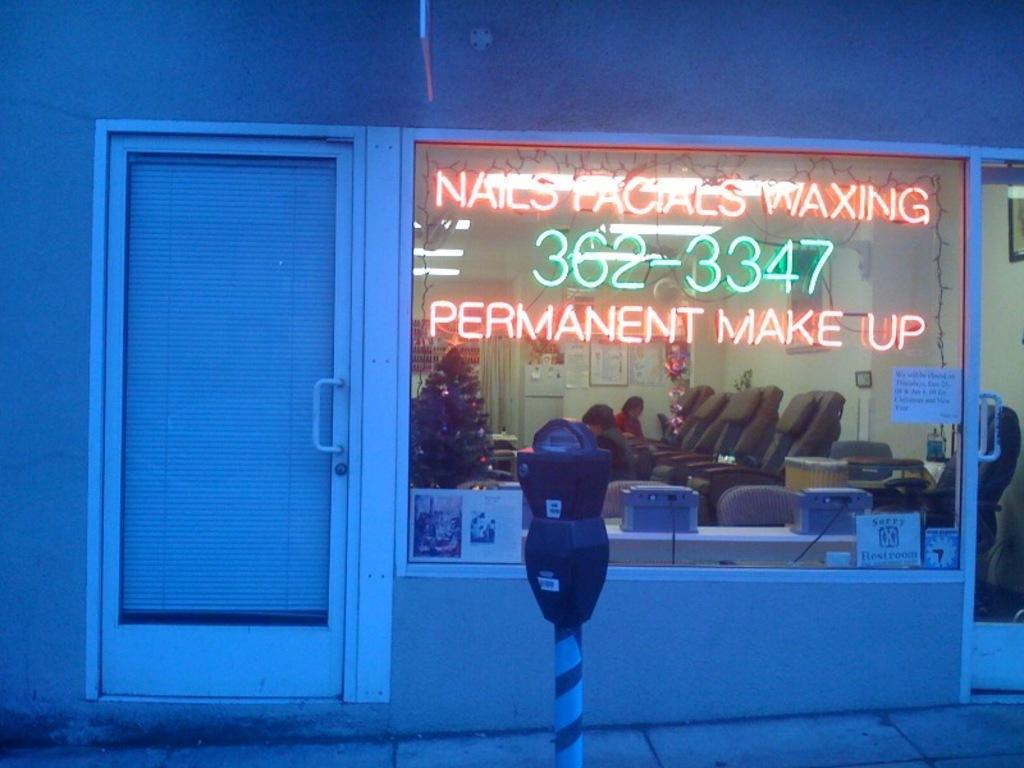In one or two sentences, can you explain what this image depicts? In front of the picture, we see a speedometer. Behind that, we see a glass window and a door from which we can see chairs, Christmas tree, a wall on which many photo frames and are placed. We even see two people sitting on the chairs. Beside that, we see a white door and beside that, we see a wall. 